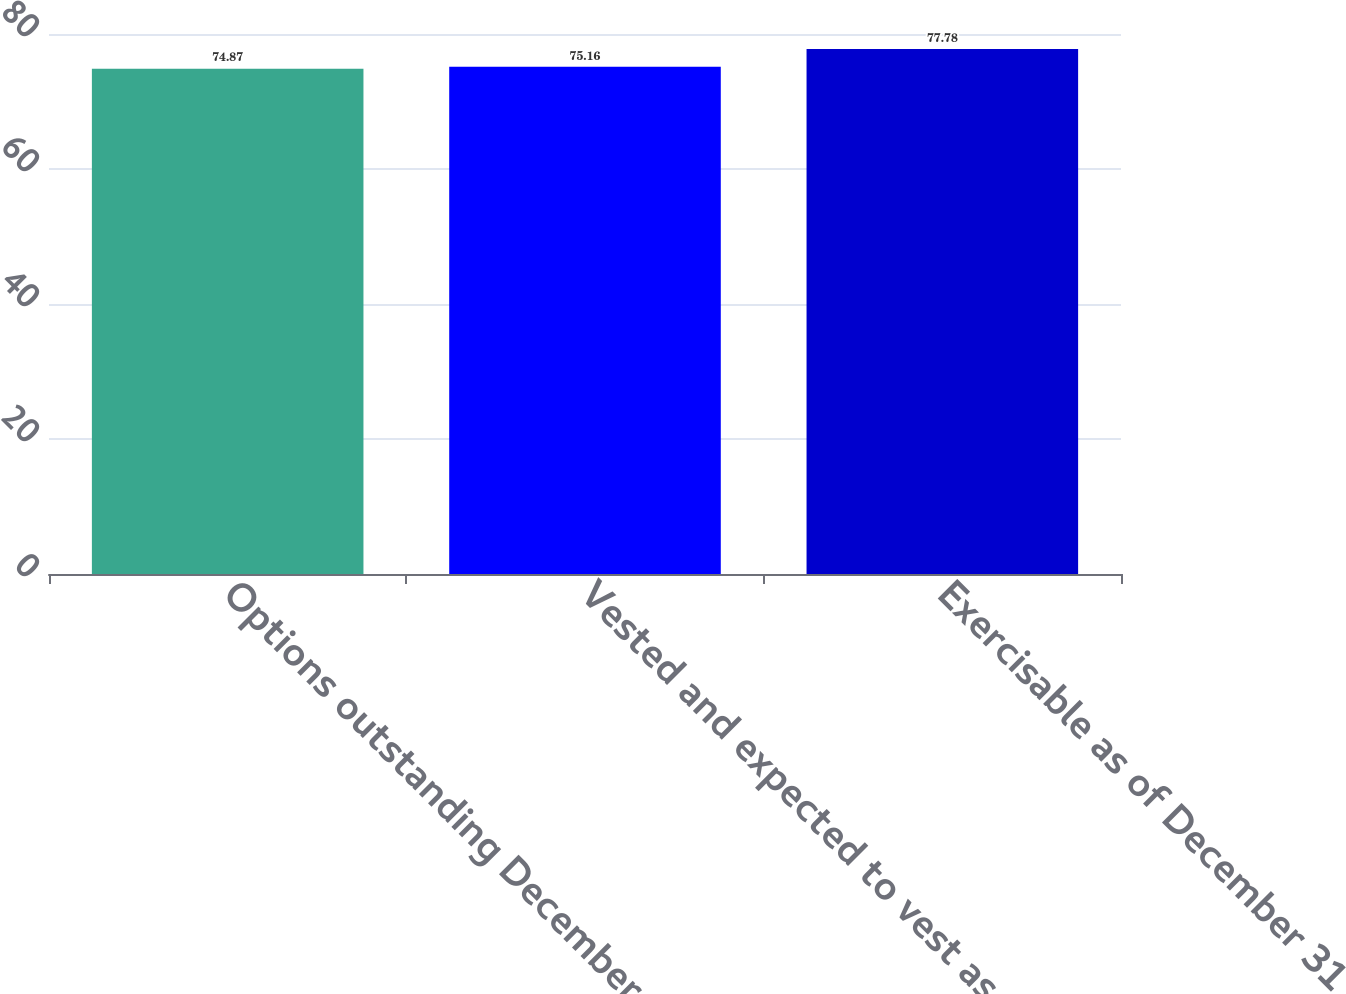Convert chart. <chart><loc_0><loc_0><loc_500><loc_500><bar_chart><fcel>Options outstanding December<fcel>Vested and expected to vest as<fcel>Exercisable as of December 31<nl><fcel>74.87<fcel>75.16<fcel>77.78<nl></chart> 